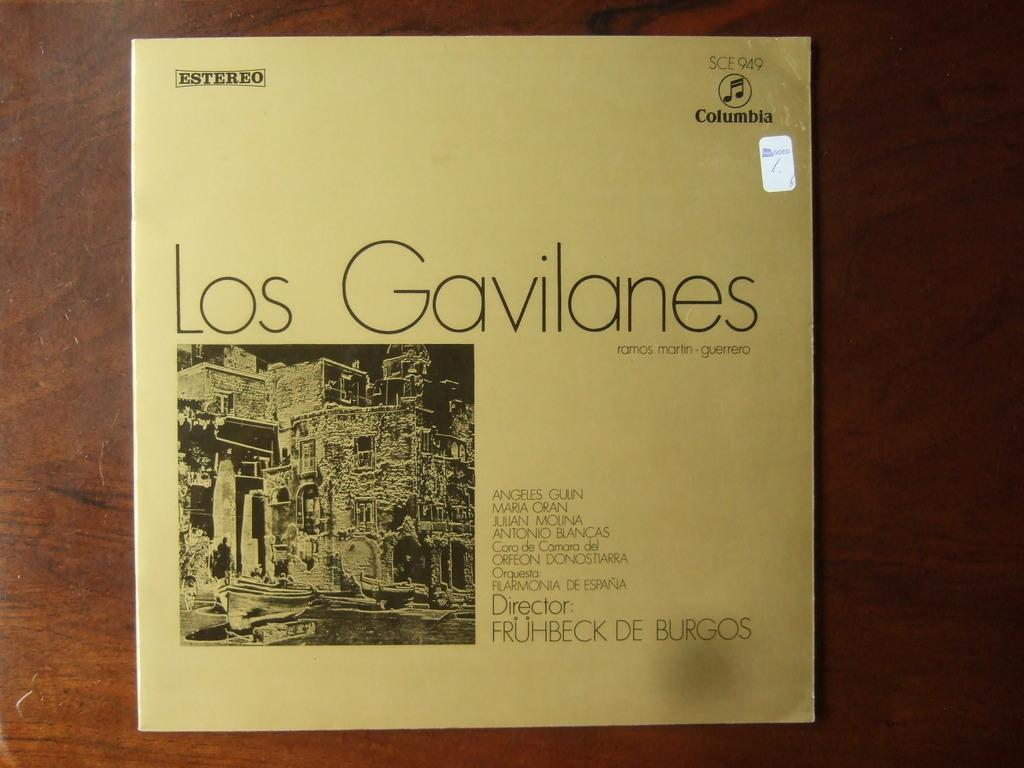Provide a one-sentence caption for the provided image. a record sleeve that reads Gavilanes is covered by a strange circle.. 